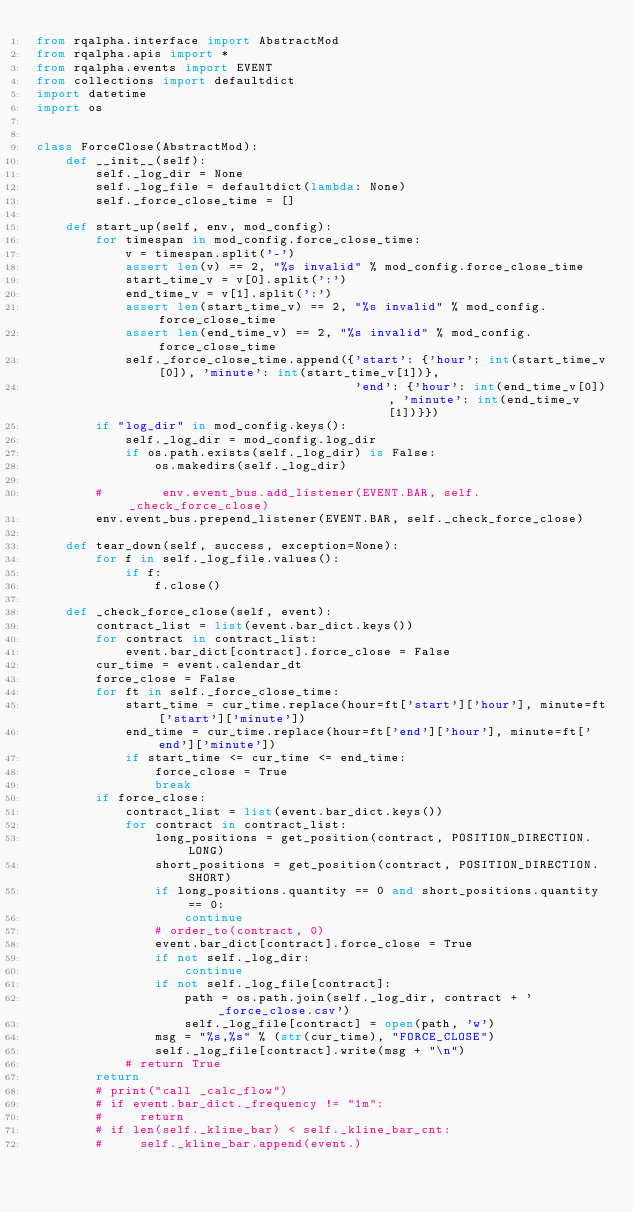<code> <loc_0><loc_0><loc_500><loc_500><_Python_>from rqalpha.interface import AbstractMod
from rqalpha.apis import *
from rqalpha.events import EVENT
from collections import defaultdict
import datetime
import os


class ForceClose(AbstractMod):
    def __init__(self):
        self._log_dir = None
        self._log_file = defaultdict(lambda: None)
        self._force_close_time = []

    def start_up(self, env, mod_config):
        for timespan in mod_config.force_close_time:
            v = timespan.split('-')
            assert len(v) == 2, "%s invalid" % mod_config.force_close_time
            start_time_v = v[0].split(':')
            end_time_v = v[1].split(':')
            assert len(start_time_v) == 2, "%s invalid" % mod_config.force_close_time
            assert len(end_time_v) == 2, "%s invalid" % mod_config.force_close_time
            self._force_close_time.append({'start': {'hour': int(start_time_v[0]), 'minute': int(start_time_v[1])},
                                           'end': {'hour': int(end_time_v[0]), 'minute': int(end_time_v[1])}})
        if "log_dir" in mod_config.keys():
            self._log_dir = mod_config.log_dir
            if os.path.exists(self._log_dir) is False:
                os.makedirs(self._log_dir)

        #        env.event_bus.add_listener(EVENT.BAR, self._check_force_close)
        env.event_bus.prepend_listener(EVENT.BAR, self._check_force_close)

    def tear_down(self, success, exception=None):
        for f in self._log_file.values():
            if f:
                f.close()

    def _check_force_close(self, event):
        contract_list = list(event.bar_dict.keys())
        for contract in contract_list:
            event.bar_dict[contract].force_close = False
        cur_time = event.calendar_dt
        force_close = False
        for ft in self._force_close_time:
            start_time = cur_time.replace(hour=ft['start']['hour'], minute=ft['start']['minute'])
            end_time = cur_time.replace(hour=ft['end']['hour'], minute=ft['end']['minute'])
            if start_time <= cur_time <= end_time:
                force_close = True
                break
        if force_close:
            contract_list = list(event.bar_dict.keys())
            for contract in contract_list:
                long_positions = get_position(contract, POSITION_DIRECTION.LONG)
                short_positions = get_position(contract, POSITION_DIRECTION.SHORT)
                if long_positions.quantity == 0 and short_positions.quantity == 0:
                    continue
                # order_to(contract, 0)
                event.bar_dict[contract].force_close = True
                if not self._log_dir:
                    continue
                if not self._log_file[contract]:
                    path = os.path.join(self._log_dir, contract + '_force_close.csv')
                    self._log_file[contract] = open(path, 'w')
                msg = "%s,%s" % (str(cur_time), "FORCE_CLOSE")
                self._log_file[contract].write(msg + "\n")
            # return True
        return
        # print("call _calc_flow")
        # if event.bar_dict._frequency != "1m":
        #     return
        # if len(self._kline_bar) < self._kline_bar_cnt:
        #     self._kline_bar.append(event.)
</code> 